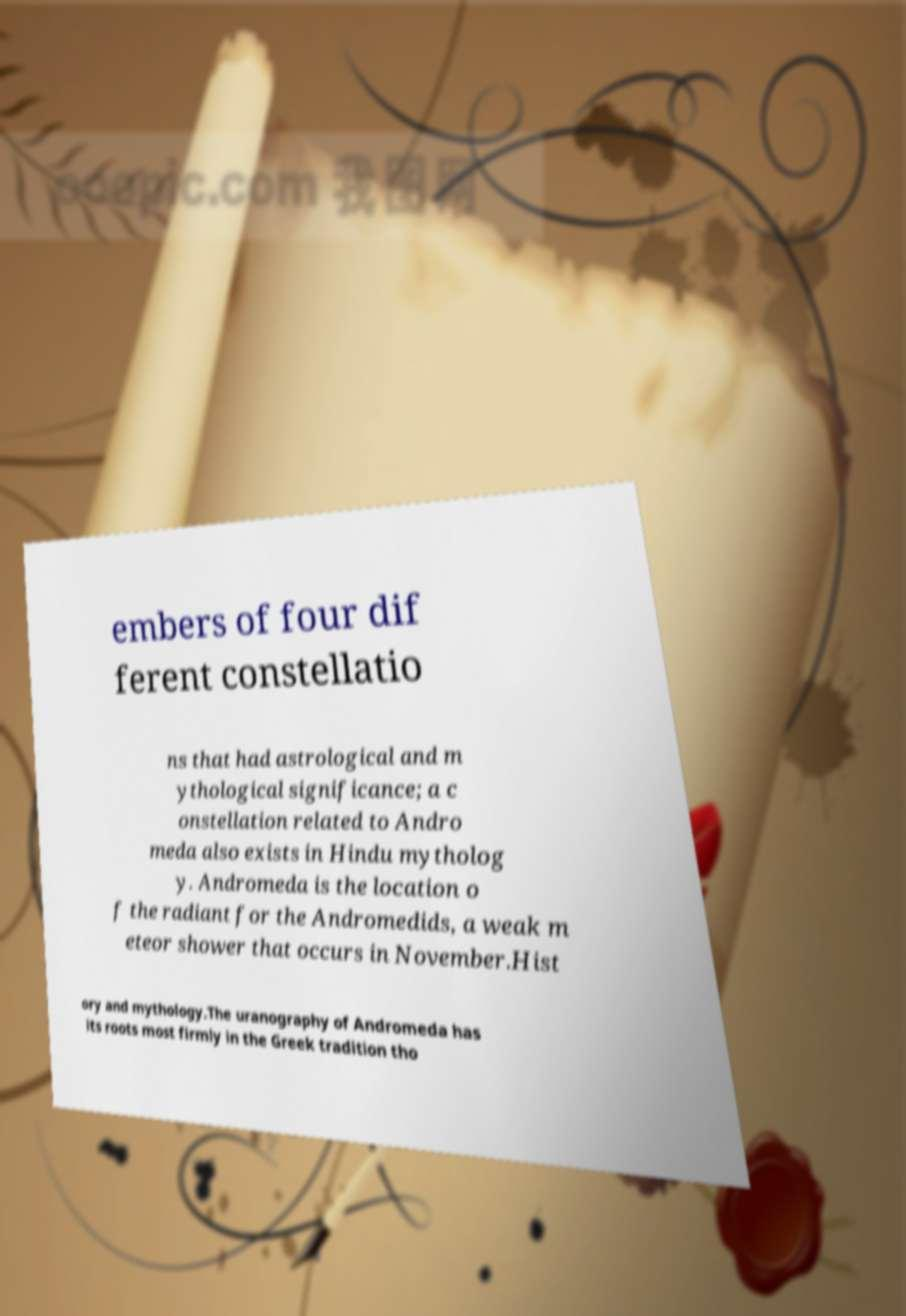Can you read and provide the text displayed in the image?This photo seems to have some interesting text. Can you extract and type it out for me? embers of four dif ferent constellatio ns that had astrological and m ythological significance; a c onstellation related to Andro meda also exists in Hindu mytholog y. Andromeda is the location o f the radiant for the Andromedids, a weak m eteor shower that occurs in November.Hist ory and mythology.The uranography of Andromeda has its roots most firmly in the Greek tradition tho 